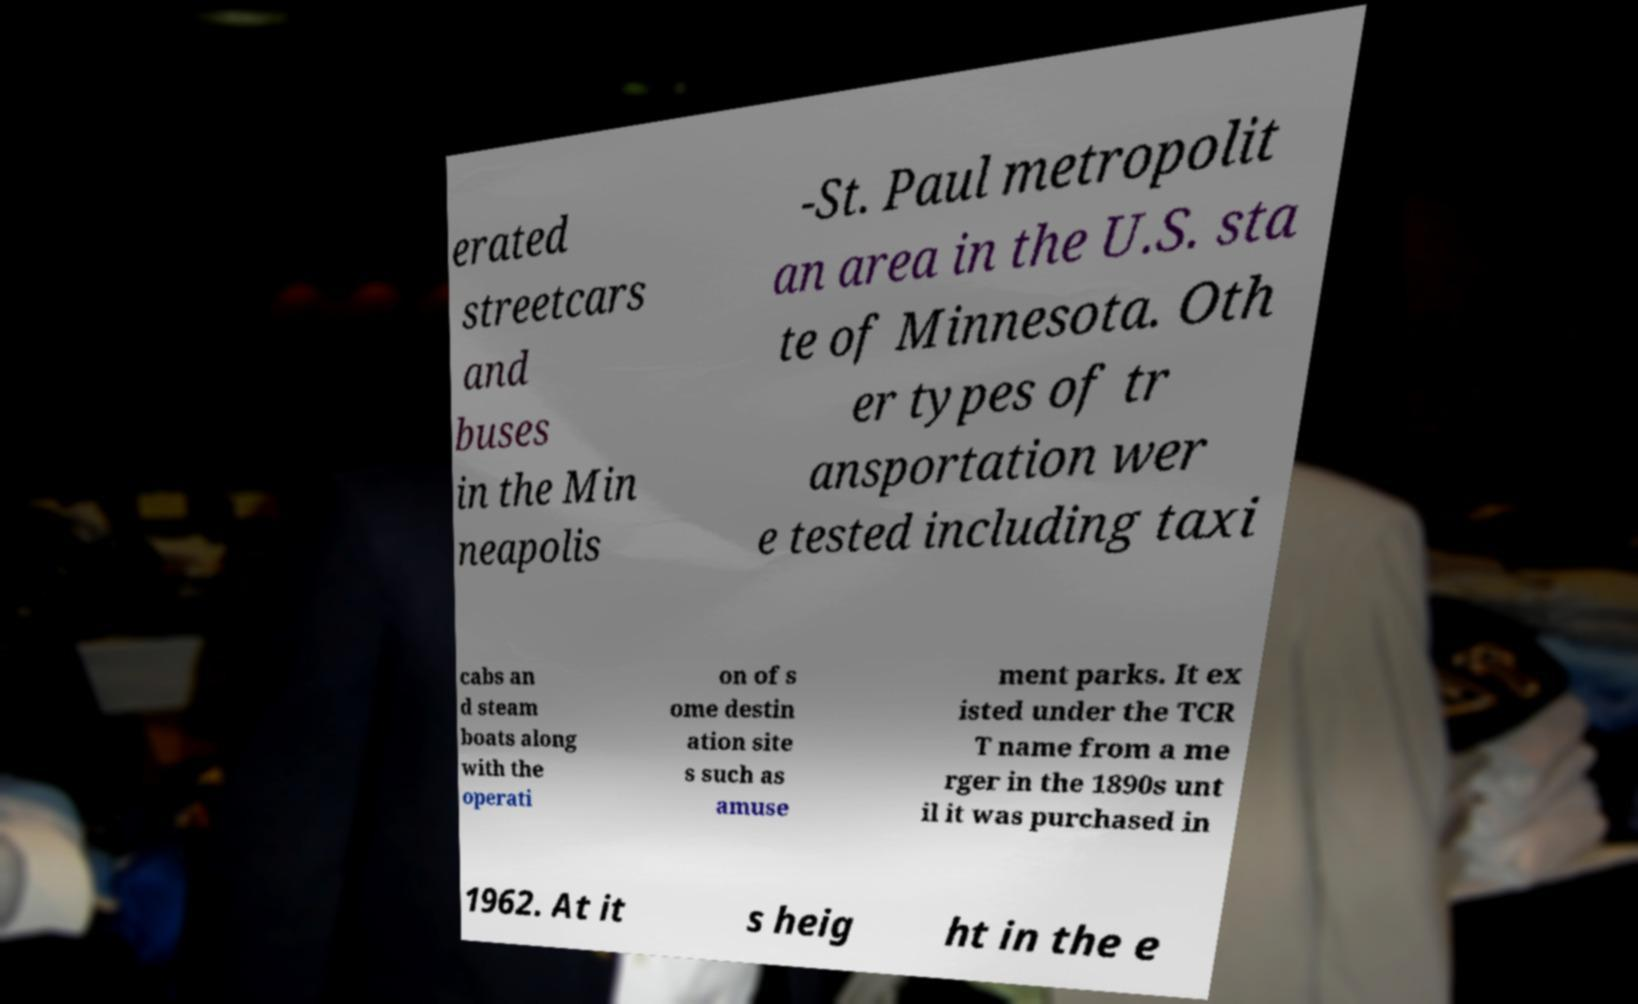There's text embedded in this image that I need extracted. Can you transcribe it verbatim? erated streetcars and buses in the Min neapolis -St. Paul metropolit an area in the U.S. sta te of Minnesota. Oth er types of tr ansportation wer e tested including taxi cabs an d steam boats along with the operati on of s ome destin ation site s such as amuse ment parks. It ex isted under the TCR T name from a me rger in the 1890s unt il it was purchased in 1962. At it s heig ht in the e 